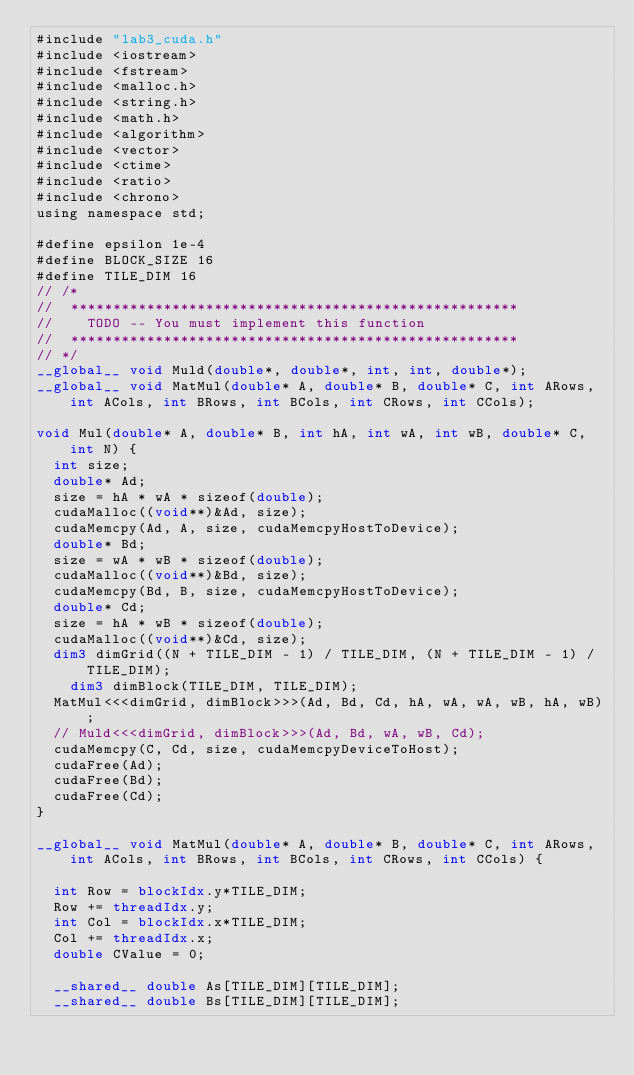Convert code to text. <code><loc_0><loc_0><loc_500><loc_500><_Cuda_>#include "lab3_cuda.h"
#include <iostream>
#include <fstream>
#include <malloc.h>
#include <string.h>
#include <math.h>
#include <algorithm>
#include <vector>
#include <ctime>
#include <ratio>
#include <chrono>
using namespace std;

#define epsilon 1e-4
#define BLOCK_SIZE 16
#define TILE_DIM 16
// /*
// 	*****************************************************
// 		TODO -- You must implement this function
// 	*****************************************************
// */
__global__ void Muld(double*, double*, int, int, double*);
__global__ void MatMul(double* A, double* B, double* C, int ARows, int ACols, int BRows, int BCols, int CRows, int CCols);

void Mul(double* A, double* B, int hA, int wA, int wB, double* C, int N) {
	int size; 
	double* Ad;
	size = hA * wA * sizeof(double);
	cudaMalloc((void**)&Ad, size);
	cudaMemcpy(Ad, A, size, cudaMemcpyHostToDevice);
	double* Bd;
	size = wA * wB * sizeof(double);
	cudaMalloc((void**)&Bd, size);
	cudaMemcpy(Bd, B, size, cudaMemcpyHostToDevice); 
	double* Cd;
	size = hA * wB * sizeof(double);
	cudaMalloc((void**)&Cd, size);
	dim3 dimGrid((N + TILE_DIM - 1) / TILE_DIM, (N + TILE_DIM - 1) / TILE_DIM);
    dim3 dimBlock(TILE_DIM, TILE_DIM);
	MatMul<<<dimGrid, dimBlock>>>(Ad, Bd, Cd, hA, wA, wA, wB, hA, wB);
	// Muld<<<dimGrid, dimBlock>>>(Ad, Bd, wA, wB, Cd);
	cudaMemcpy(C, Cd, size, cudaMemcpyDeviceToHost);
	cudaFree(Ad);
	cudaFree(Bd);
	cudaFree(Cd);
}

__global__ void MatMul(double* A, double* B, double* C, int ARows, int ACols, int BRows, int BCols, int CRows, int CCols) {

  int Row = blockIdx.y*TILE_DIM;
  Row += threadIdx.y;
  int Col = blockIdx.x*TILE_DIM;
  Col += threadIdx.x;
  double CValue = 0;

  __shared__ double As[TILE_DIM][TILE_DIM];
  __shared__ double Bs[TILE_DIM][TILE_DIM];
</code> 